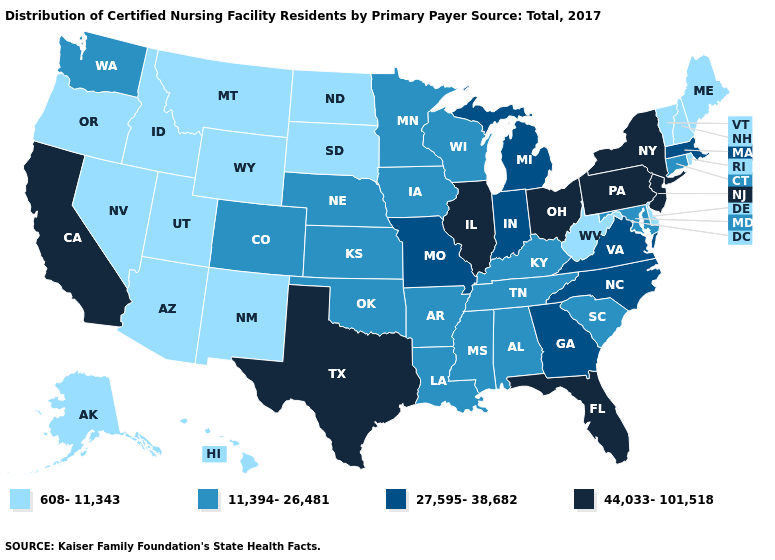What is the highest value in states that border Pennsylvania?
Be succinct. 44,033-101,518. Does the first symbol in the legend represent the smallest category?
Answer briefly. Yes. Which states have the lowest value in the South?
Quick response, please. Delaware, West Virginia. Name the states that have a value in the range 44,033-101,518?
Quick response, please. California, Florida, Illinois, New Jersey, New York, Ohio, Pennsylvania, Texas. Name the states that have a value in the range 11,394-26,481?
Answer briefly. Alabama, Arkansas, Colorado, Connecticut, Iowa, Kansas, Kentucky, Louisiana, Maryland, Minnesota, Mississippi, Nebraska, Oklahoma, South Carolina, Tennessee, Washington, Wisconsin. Does Florida have the highest value in the South?
Be succinct. Yes. What is the highest value in the West ?
Short answer required. 44,033-101,518. What is the value of Alaska?
Short answer required. 608-11,343. What is the highest value in the West ?
Answer briefly. 44,033-101,518. Does New Jersey have the lowest value in the Northeast?
Answer briefly. No. What is the highest value in the USA?
Give a very brief answer. 44,033-101,518. Which states hav the highest value in the Northeast?
Quick response, please. New Jersey, New York, Pennsylvania. What is the value of Hawaii?
Quick response, please. 608-11,343. What is the value of Arkansas?
Quick response, please. 11,394-26,481. 